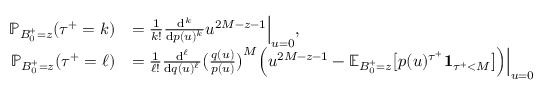Convert formula to latex. <formula><loc_0><loc_0><loc_500><loc_500>\begin{array} { r l } { \mathbb { P } _ { B _ { 0 } ^ { + } = z } ( { \tau ^ { + } } = k ) } & { = \frac { 1 } { k ! } \frac { d ^ { k } } { d p ( u ) ^ { k } } u ^ { 2 M - z - 1 } \left | _ { u = 0 } , } \\ { \mathbb { P } _ { B _ { 0 } ^ { + } = z } ( { \tau ^ { + } } = \ell ) } & { = \frac { 1 } { \ell ! } \frac { d ^ { \ell } } { d q ( u ) ^ { \ell } } \left ( \frac { q ( u ) } { p ( u ) } \right ) ^ { M } \left ( u ^ { 2 M - z - 1 } - \mathbb { E } _ { B _ { 0 } ^ { + } = z } \left [ p ( u ) ^ { \tau ^ { + } } 1 _ { { \tau ^ { + } } < M } \right ] \right ) \right | _ { u = 0 } } \end{array}</formula> 